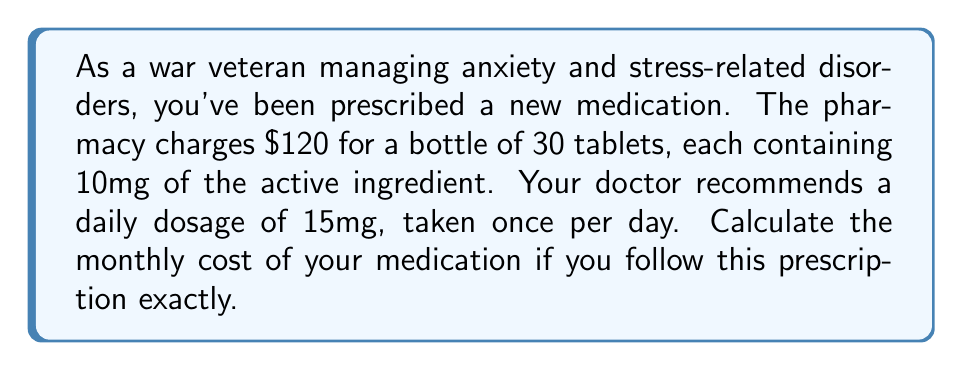Can you solve this math problem? Let's break this problem down step-by-step:

1. Understand the given information:
   * Cost of medication: $120 for 30 tablets
   * Each tablet contains 10mg of the active ingredient
   * Prescribed daily dosage: 15mg once per day

2. Calculate the number of tablets needed per day:
   $$ \text{Tablets per day} = \frac{\text{Prescribed daily dosage}}{\text{Dosage per tablet}} = \frac{15\text{mg}}{10\text{mg}} = 1.5 \text{ tablets} $$

3. Calculate the number of tablets needed for a 30-day month:
   $$ \text{Tablets per month} = 1.5 \text{ tablets} \times 30 \text{ days} = 45 \text{ tablets} $$

4. Calculate the number of bottles needed per month:
   $$ \text{Bottles per month} = \frac{\text{Tablets per month}}{\text{Tablets per bottle}} = \frac{45}{30} = 1.5 \text{ bottles} $$

5. Calculate the monthly cost:
   $$ \text{Monthly cost} = \text{Cost per bottle} \times \text{Bottles per month} $$
   $$ \text{Monthly cost} = \$120 \times 1.5 = \$180 $$

Therefore, the monthly cost of your medication will be $180.
Answer: $180 